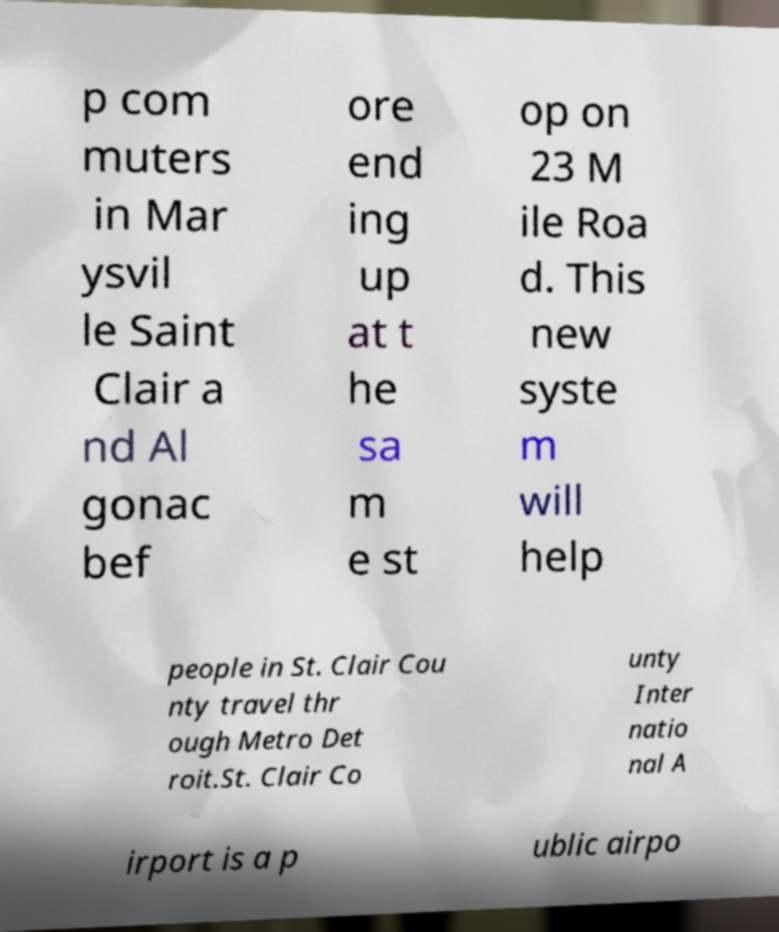Please identify and transcribe the text found in this image. p com muters in Mar ysvil le Saint Clair a nd Al gonac bef ore end ing up at t he sa m e st op on 23 M ile Roa d. This new syste m will help people in St. Clair Cou nty travel thr ough Metro Det roit.St. Clair Co unty Inter natio nal A irport is a p ublic airpo 